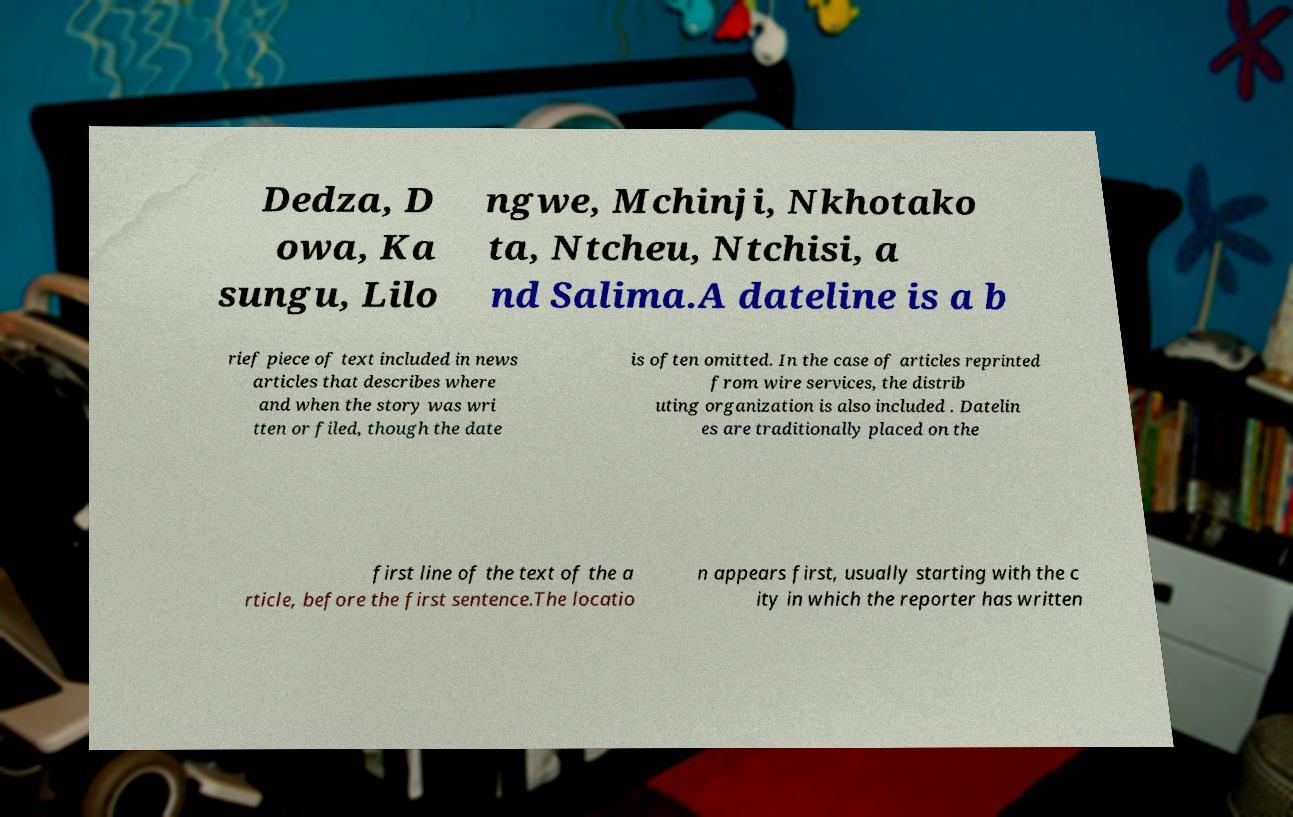I need the written content from this picture converted into text. Can you do that? Dedza, D owa, Ka sungu, Lilo ngwe, Mchinji, Nkhotako ta, Ntcheu, Ntchisi, a nd Salima.A dateline is a b rief piece of text included in news articles that describes where and when the story was wri tten or filed, though the date is often omitted. In the case of articles reprinted from wire services, the distrib uting organization is also included . Datelin es are traditionally placed on the first line of the text of the a rticle, before the first sentence.The locatio n appears first, usually starting with the c ity in which the reporter has written 